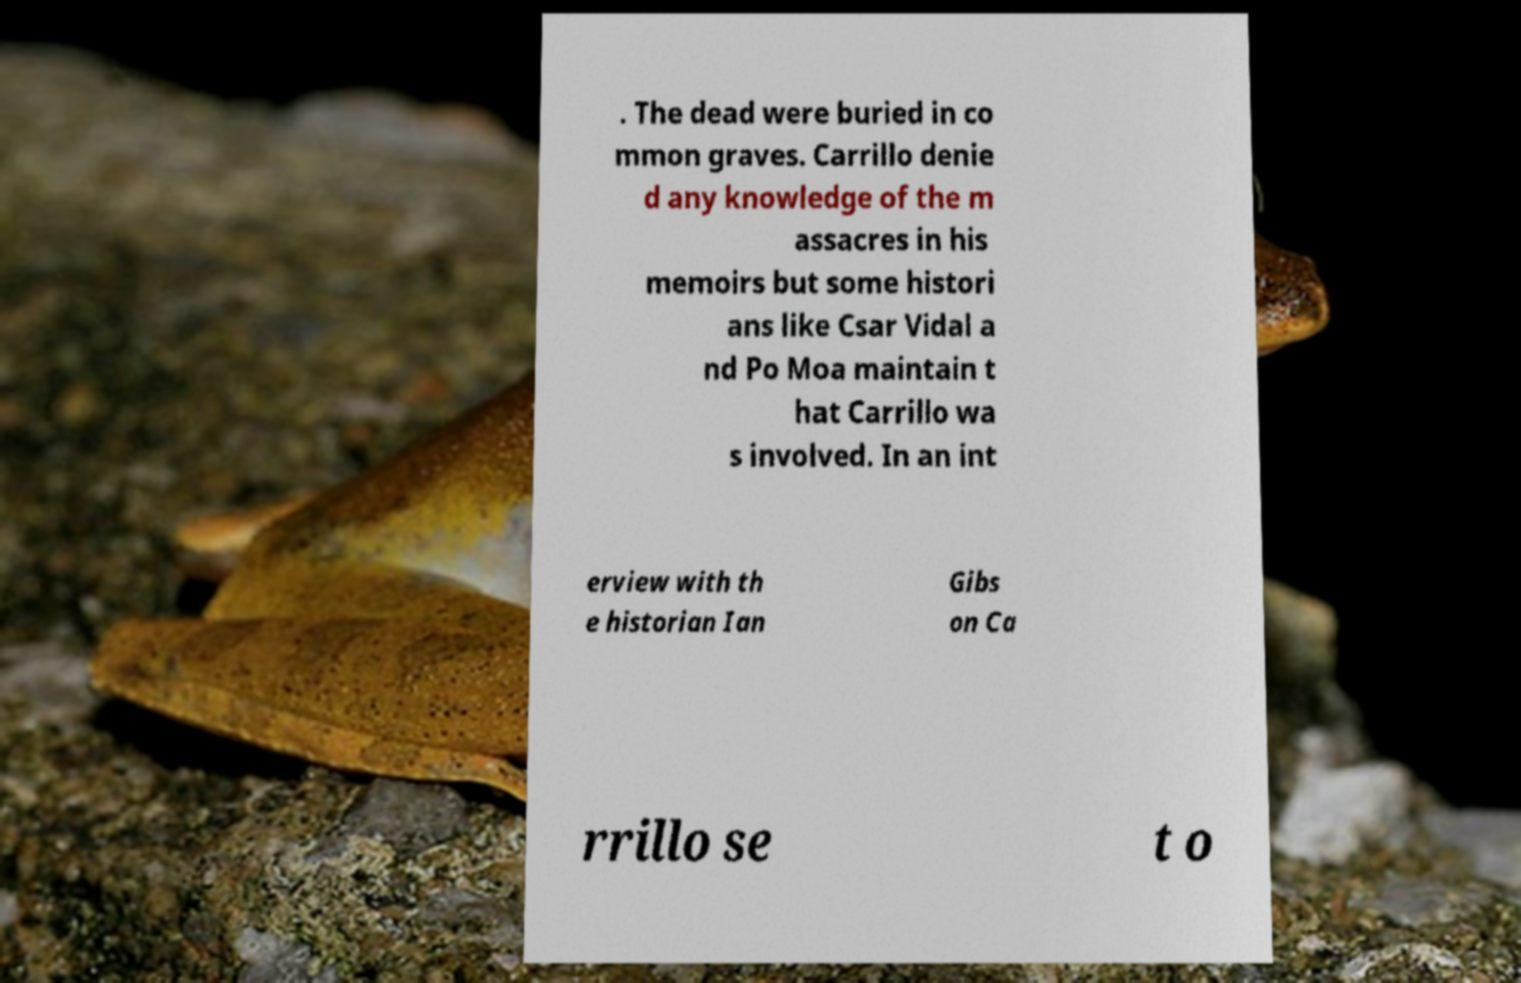Can you accurately transcribe the text from the provided image for me? . The dead were buried in co mmon graves. Carrillo denie d any knowledge of the m assacres in his memoirs but some histori ans like Csar Vidal a nd Po Moa maintain t hat Carrillo wa s involved. In an int erview with th e historian Ian Gibs on Ca rrillo se t o 